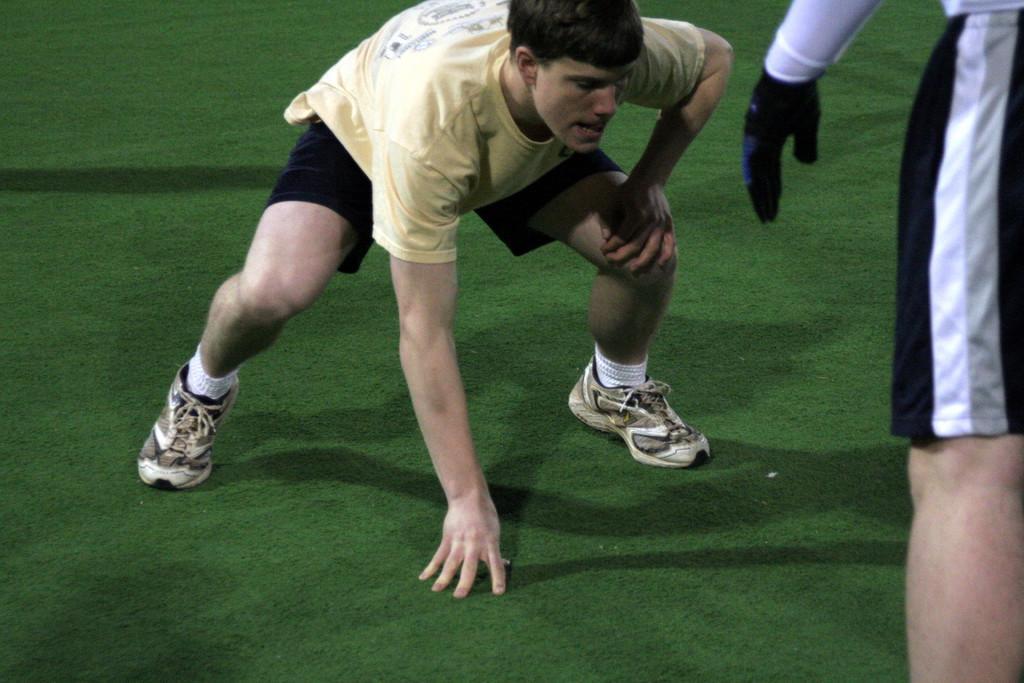In one or two sentences, can you explain what this image depicts? In the center of the picture there is a person. On the right there is another person standing. In this picture there is a grass court. 